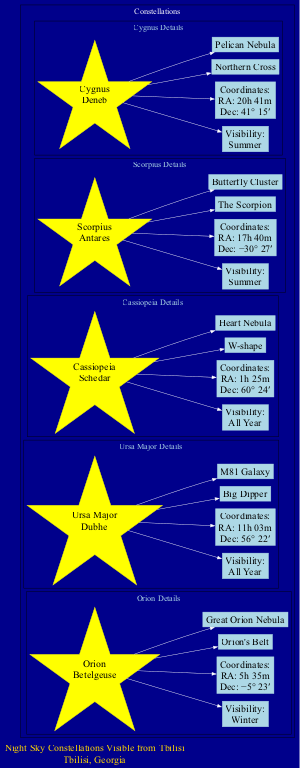What is the brightest star in Orion? The diagram shows that the brightest star in the constellation Orion is Betelgeuse.
Answer: Betelgeuse How many notable features are listed for Ursa Major? The diagram indicates that there are two notable features listed for Ursa Major: Big Dipper and M81 Galaxy.
Answer: 2 Which constellation is visible in summer? The diagram highlights Scorpius and Cygnus as the constellations that are visible in summer.
Answer: Scorpius, Cygnus What are the coordinates of Cassiopeia? The diagram lists the coordinates of Cassiopeia as Right Ascension: 1h 25m and Declination: 60° 24′.
Answer: RA: 1h 25m, Dec: 60° 24′ Which constellation has the notable feature "Great Orion Nebula"? According to the diagram, the notable feature "Great Orion Nebula" is associated with the constellation Orion.
Answer: Orion Which constellation is visible all year round? The diagram states that both Ursa Major and Cassiopeia are visible all year round.
Answer: Ursa Major, Cassiopeia What is the brightest star in Scorpius? The diagram shows that the brightest star in Scorpius is Antares.
Answer: Antares How many constellations are depicted in the diagram? The diagram reveals that there are five constellations depicted.
Answer: 5 What unique shape is associated with Cassiopeia? The diagram describes Cassiopeia as having a W-shape as a notable feature.
Answer: W-shape 